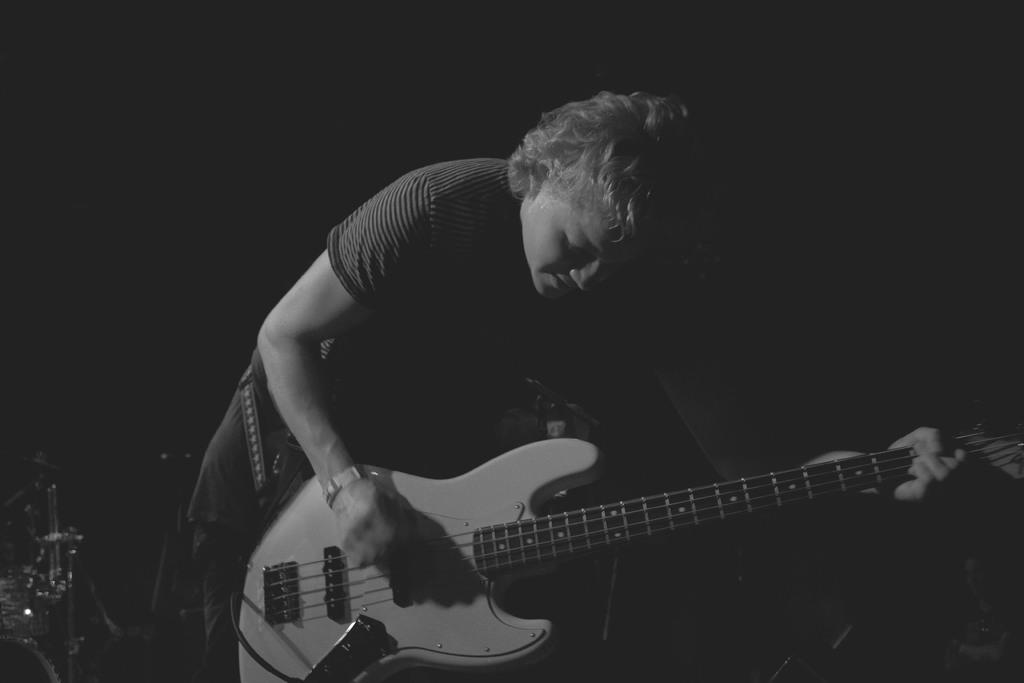Who is the main subject in the image? There is the woman in the image. What is the woman wearing in the image? The woman is dressed in yellow. What object is the woman holding in the image? The woman is holding a guitar. What type of business is the woman running in the image? There is no indication of a business in the image; it only shows a woman holding a guitar. Is the woman's toe visible in the image? The provided facts do not mention anything about the woman's toe, so it cannot be determined if it is visible in the image. 